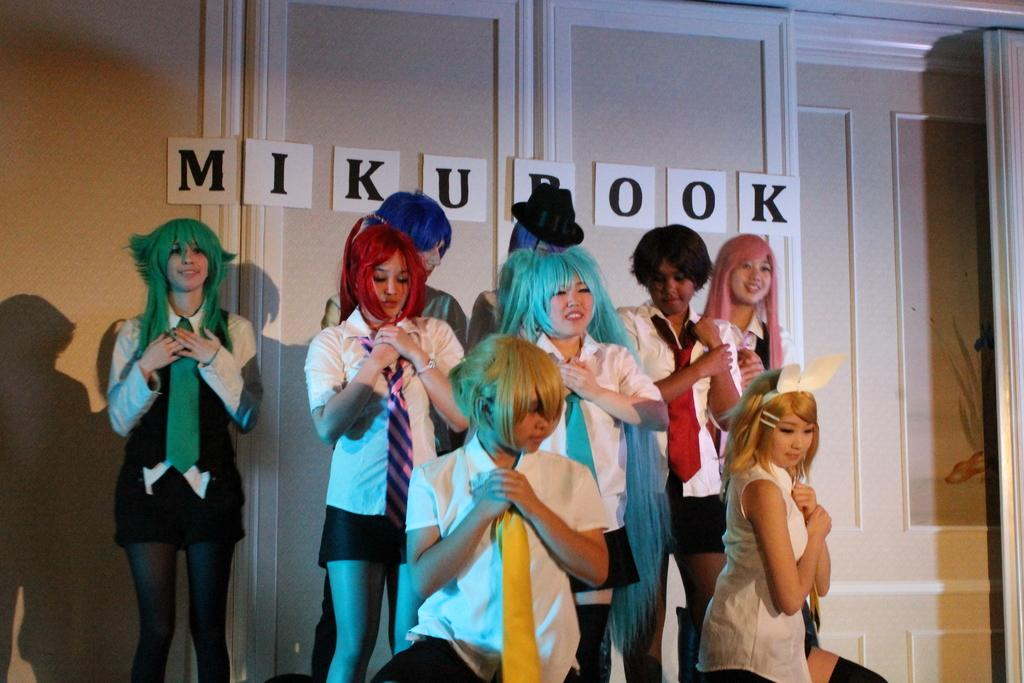What is a notable characteristic of some people in the image? There are people with colored hair in the image. Can you describe the attire of one of the individuals? There is a person wearing a hat in the image. What can be seen in the background of the image? There is a wall and letter boards in the background of the image. What type of flower is growing on the hat of the person in the image? There is no flower present on the hat of the person in the image. Can you describe the scene where the giraffe is interacting with the letter boards in the image? There is no giraffe present in the image; it only features people with colored hair, a person wearing a hat, a wall, and letter boards. 